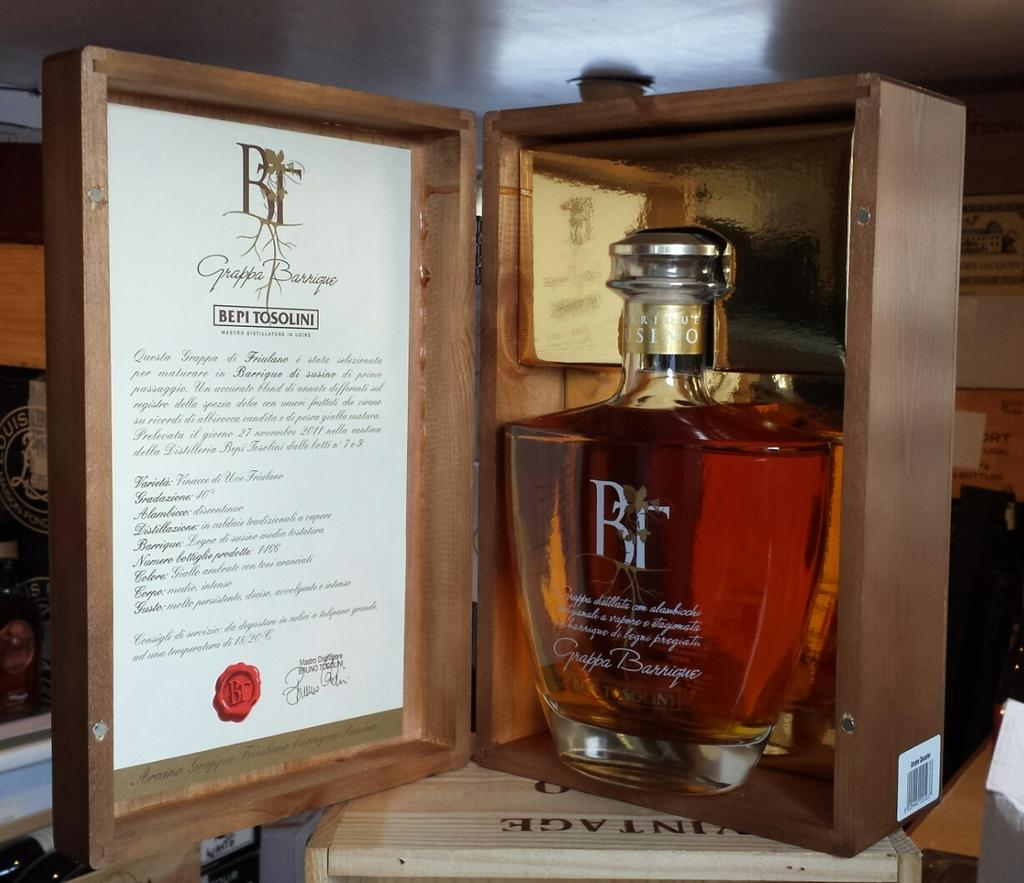<image>
Offer a succinct explanation of the picture presented. A bottle of Bepi Tosolini in a brown box. 